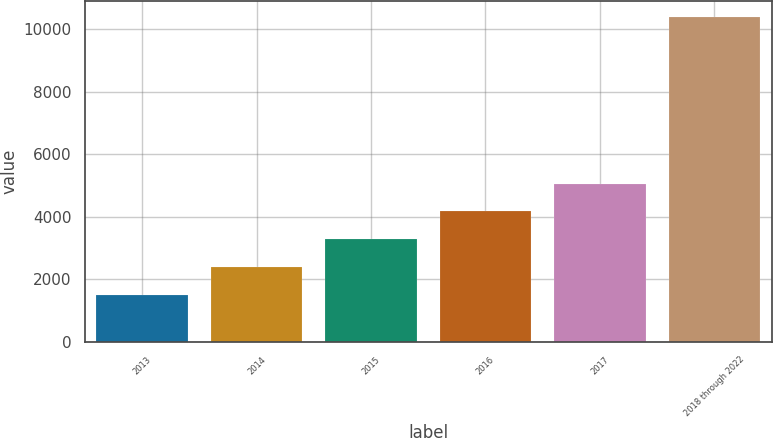<chart> <loc_0><loc_0><loc_500><loc_500><bar_chart><fcel>2013<fcel>2014<fcel>2015<fcel>2016<fcel>2017<fcel>2018 through 2022<nl><fcel>1510<fcel>2397.1<fcel>3284.2<fcel>4171.3<fcel>5058.4<fcel>10381<nl></chart> 